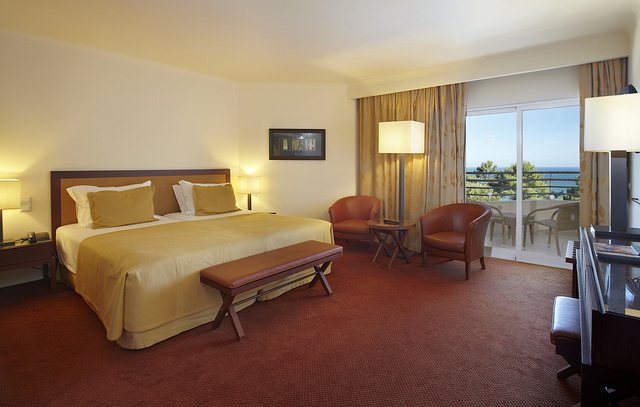How many people are carrying surfboards? There are no people visible in the image, therefore no one is carrying surfboards. The image shows an interior view of a hotel room with a bed, chairs, and a view of the outside from a balcony. 